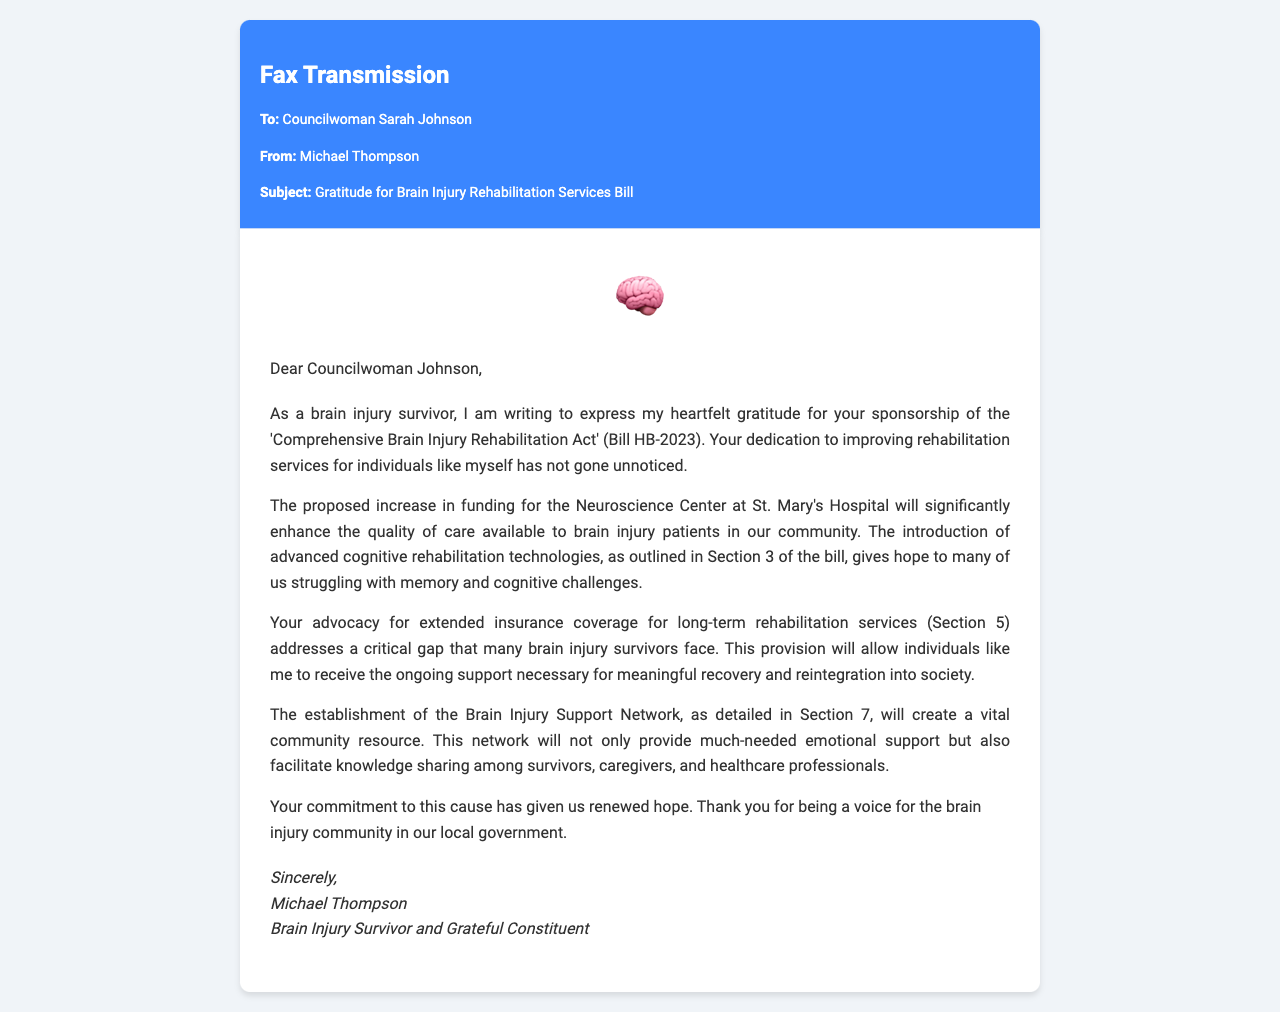What is the name of the bill mentioned? The document refers to the 'Comprehensive Brain Injury Rehabilitation Act' as Bill HB-2023.
Answer: Comprehensive Brain Injury Rehabilitation Act Who is the sender of the fax? The sender of the fax is Michael Thompson.
Answer: Michael Thompson What is the role of the recipient? The recipient of the fax is identified as Councilwoman.
Answer: Councilwoman What community resource will be established as per Section 7? The document mentions the establishment of the Brain Injury Support Network.
Answer: Brain Injury Support Network How does the bill plan to improve rehabilitation services? The bill proposes an increase in funding for the Neuroscience Center at St. Mary's Hospital.
Answer: Increase in funding for the Neuroscience Center What is emphasized as necessary for meaningful recovery in Section 5? The fax highlights the need for extended insurance coverage for long-term rehabilitation services.
Answer: Extended insurance coverage What benefit does Section 3 offer to brain injury patients? Section 3 introduces advanced cognitive rehabilitation technologies, which enhance care quality.
Answer: Advanced cognitive rehabilitation technologies What feeling does the closing statement express? The closing statement expresses gratitude and renewed hope for the brain injury community.
Answer: Gratitude and renewed hope 